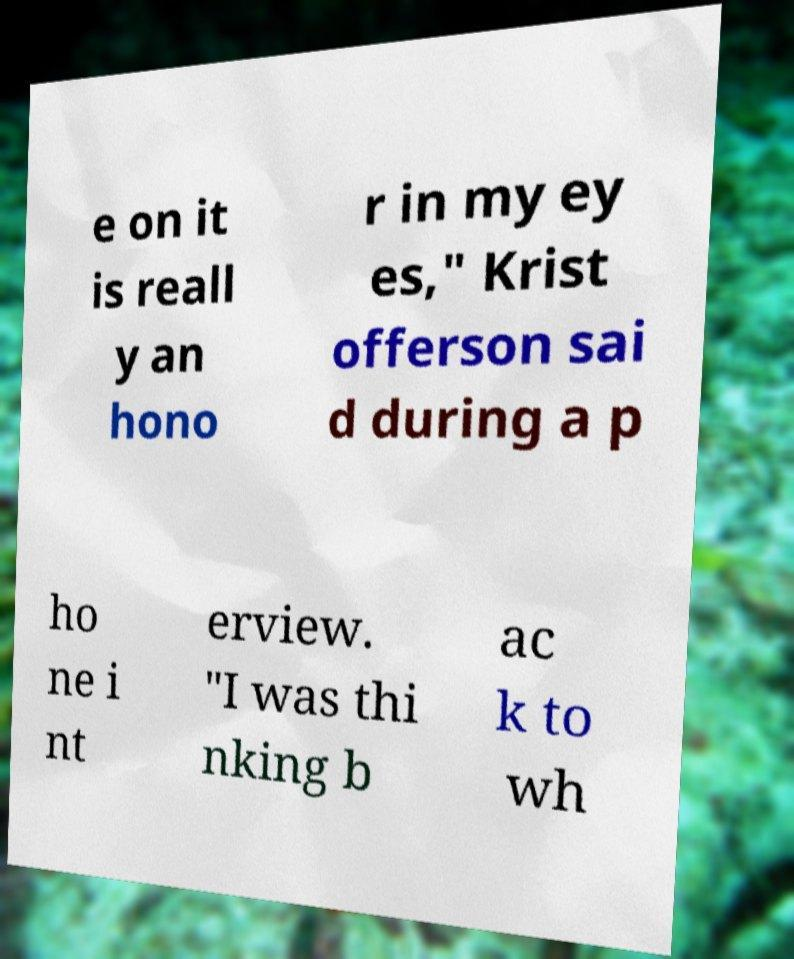Could you extract and type out the text from this image? e on it is reall y an hono r in my ey es," Krist offerson sai d during a p ho ne i nt erview. "I was thi nking b ac k to wh 